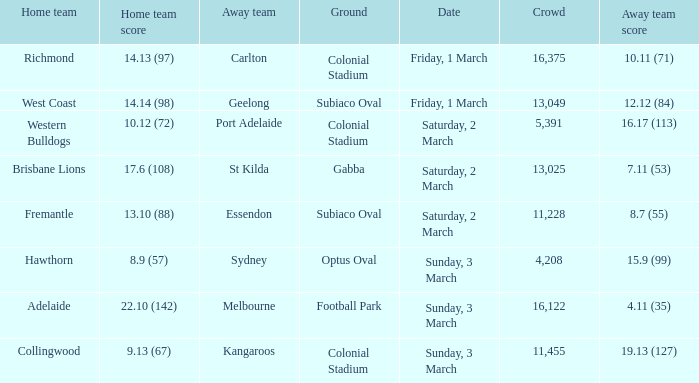What was the ground for away team essendon? Subiaco Oval. Give me the full table as a dictionary. {'header': ['Home team', 'Home team score', 'Away team', 'Ground', 'Date', 'Crowd', 'Away team score'], 'rows': [['Richmond', '14.13 (97)', 'Carlton', 'Colonial Stadium', 'Friday, 1 March', '16,375', '10.11 (71)'], ['West Coast', '14.14 (98)', 'Geelong', 'Subiaco Oval', 'Friday, 1 March', '13,049', '12.12 (84)'], ['Western Bulldogs', '10.12 (72)', 'Port Adelaide', 'Colonial Stadium', 'Saturday, 2 March', '5,391', '16.17 (113)'], ['Brisbane Lions', '17.6 (108)', 'St Kilda', 'Gabba', 'Saturday, 2 March', '13,025', '7.11 (53)'], ['Fremantle', '13.10 (88)', 'Essendon', 'Subiaco Oval', 'Saturday, 2 March', '11,228', '8.7 (55)'], ['Hawthorn', '8.9 (57)', 'Sydney', 'Optus Oval', 'Sunday, 3 March', '4,208', '15.9 (99)'], ['Adelaide', '22.10 (142)', 'Melbourne', 'Football Park', 'Sunday, 3 March', '16,122', '4.11 (35)'], ['Collingwood', '9.13 (67)', 'Kangaroos', 'Colonial Stadium', 'Sunday, 3 March', '11,455', '19.13 (127)']]} 